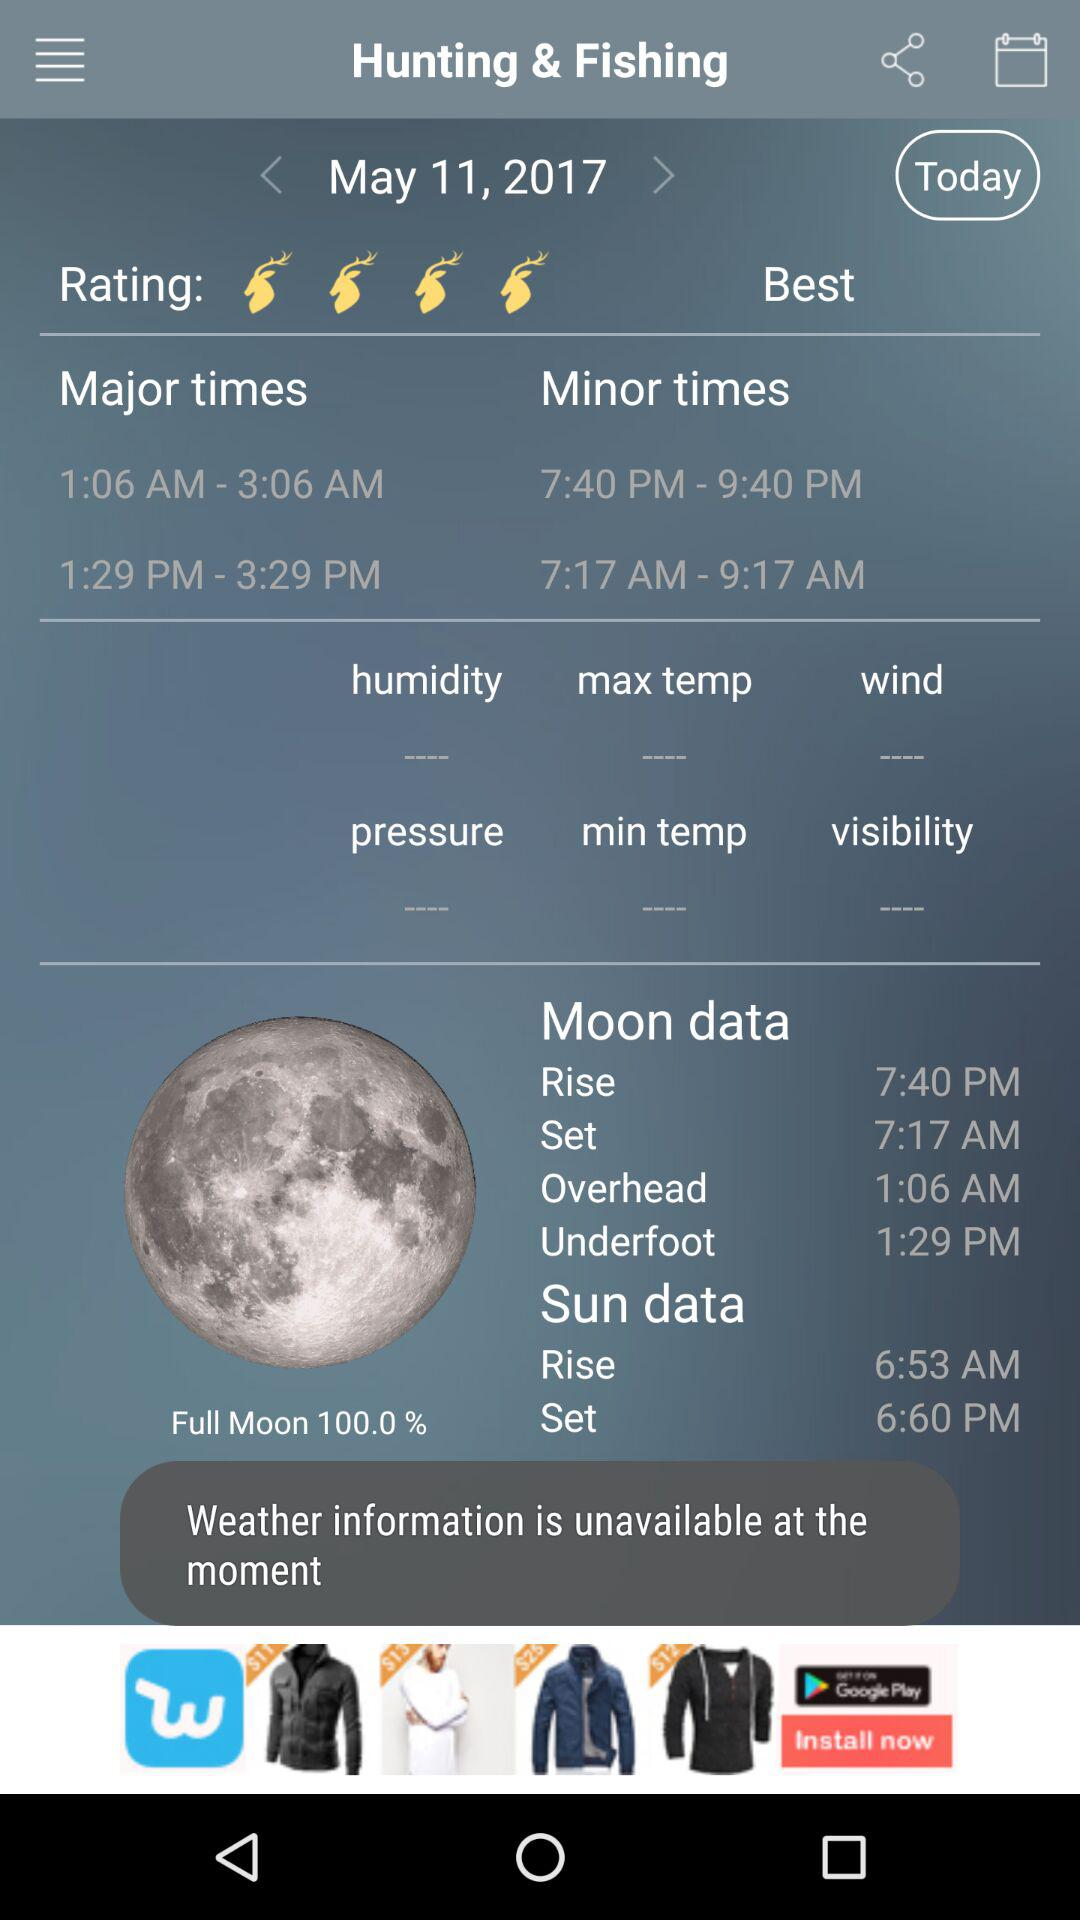What is the time of sunrise? The time of sunrise is 6:53 AM. 